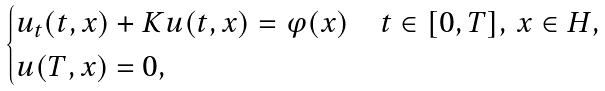<formula> <loc_0><loc_0><loc_500><loc_500>\begin{cases} u _ { t } ( t , x ) + K u ( t , x ) = \varphi ( x ) & t \in [ 0 , T ] , \, x \in H , \\ u ( T , x ) = 0 , \end{cases}</formula> 